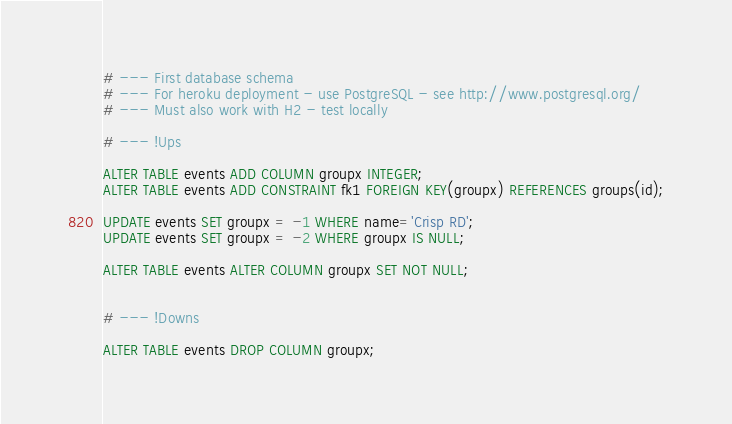Convert code to text. <code><loc_0><loc_0><loc_500><loc_500><_SQL_># --- First database schema
# --- For heroku deployment - use PostgreSQL - see http://www.postgresql.org/
# --- Must also work with H2 - test locally

# --- !Ups
 
ALTER TABLE events ADD COLUMN groupx INTEGER;
ALTER TABLE events ADD CONSTRAINT fk1 FOREIGN KEY(groupx) REFERENCES groups(id);

UPDATE events SET groupx = -1 WHERE name='Crisp RD';
UPDATE events SET groupx = -2 WHERE groupx IS NULL;

ALTER TABLE events ALTER COLUMN groupx SET NOT NULL;


# --- !Downs

ALTER TABLE events DROP COLUMN groupx;
</code> 